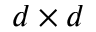<formula> <loc_0><loc_0><loc_500><loc_500>d \times d</formula> 